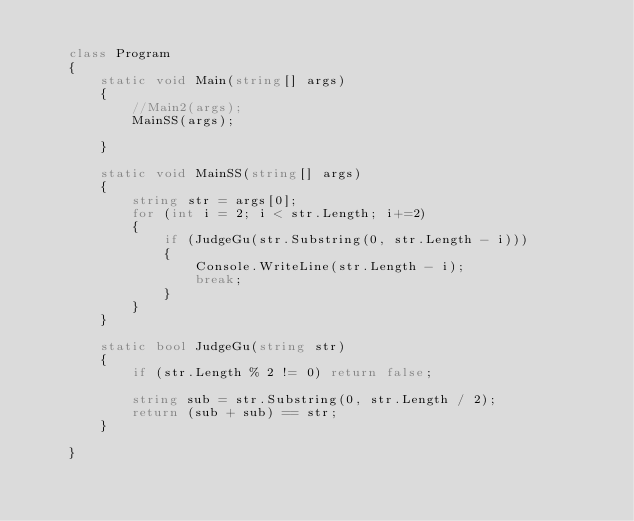Convert code to text. <code><loc_0><loc_0><loc_500><loc_500><_C#_>
    class Program
    {
        static void Main(string[] args)
        {
            //Main2(args);
            MainSS(args);

        }

        static void MainSS(string[] args)
        {
            string str = args[0];
            for (int i = 2; i < str.Length; i+=2)
            {
                if (JudgeGu(str.Substring(0, str.Length - i)))
                {
                    Console.WriteLine(str.Length - i);
                    break;
                }
            }
        }

        static bool JudgeGu(string str)
        {
            if (str.Length % 2 != 0) return false;

            string sub = str.Substring(0, str.Length / 2);
            return (sub + sub) == str;
        }

    }</code> 